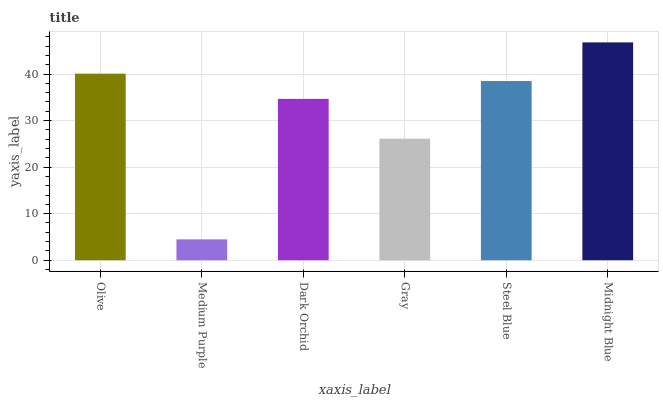Is Medium Purple the minimum?
Answer yes or no. Yes. Is Midnight Blue the maximum?
Answer yes or no. Yes. Is Dark Orchid the minimum?
Answer yes or no. No. Is Dark Orchid the maximum?
Answer yes or no. No. Is Dark Orchid greater than Medium Purple?
Answer yes or no. Yes. Is Medium Purple less than Dark Orchid?
Answer yes or no. Yes. Is Medium Purple greater than Dark Orchid?
Answer yes or no. No. Is Dark Orchid less than Medium Purple?
Answer yes or no. No. Is Steel Blue the high median?
Answer yes or no. Yes. Is Dark Orchid the low median?
Answer yes or no. Yes. Is Midnight Blue the high median?
Answer yes or no. No. Is Steel Blue the low median?
Answer yes or no. No. 